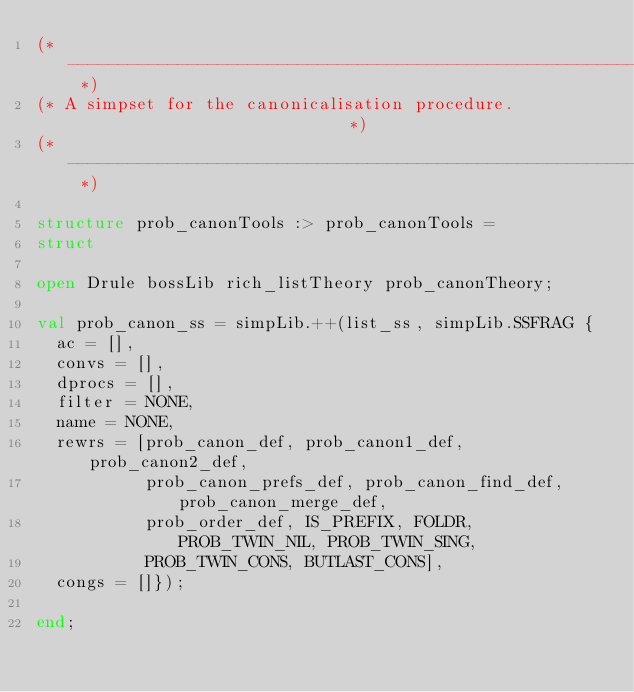<code> <loc_0><loc_0><loc_500><loc_500><_SML_>(* ------------------------------------------------------------------------- *)
(* A simpset for the canonicalisation procedure.                             *)
(* ------------------------------------------------------------------------- *)

structure prob_canonTools :> prob_canonTools =
struct

open Drule bossLib rich_listTheory prob_canonTheory;

val prob_canon_ss = simpLib.++(list_ss, simpLib.SSFRAG {
  ac = [],
  convs = [],
  dprocs = [],
  filter = NONE,
  name = NONE,
  rewrs = [prob_canon_def, prob_canon1_def, prob_canon2_def,
           prob_canon_prefs_def, prob_canon_find_def, prob_canon_merge_def,
           prob_order_def, IS_PREFIX, FOLDR, PROB_TWIN_NIL, PROB_TWIN_SING,
           PROB_TWIN_CONS, BUTLAST_CONS],
  congs = []});

end;

</code> 